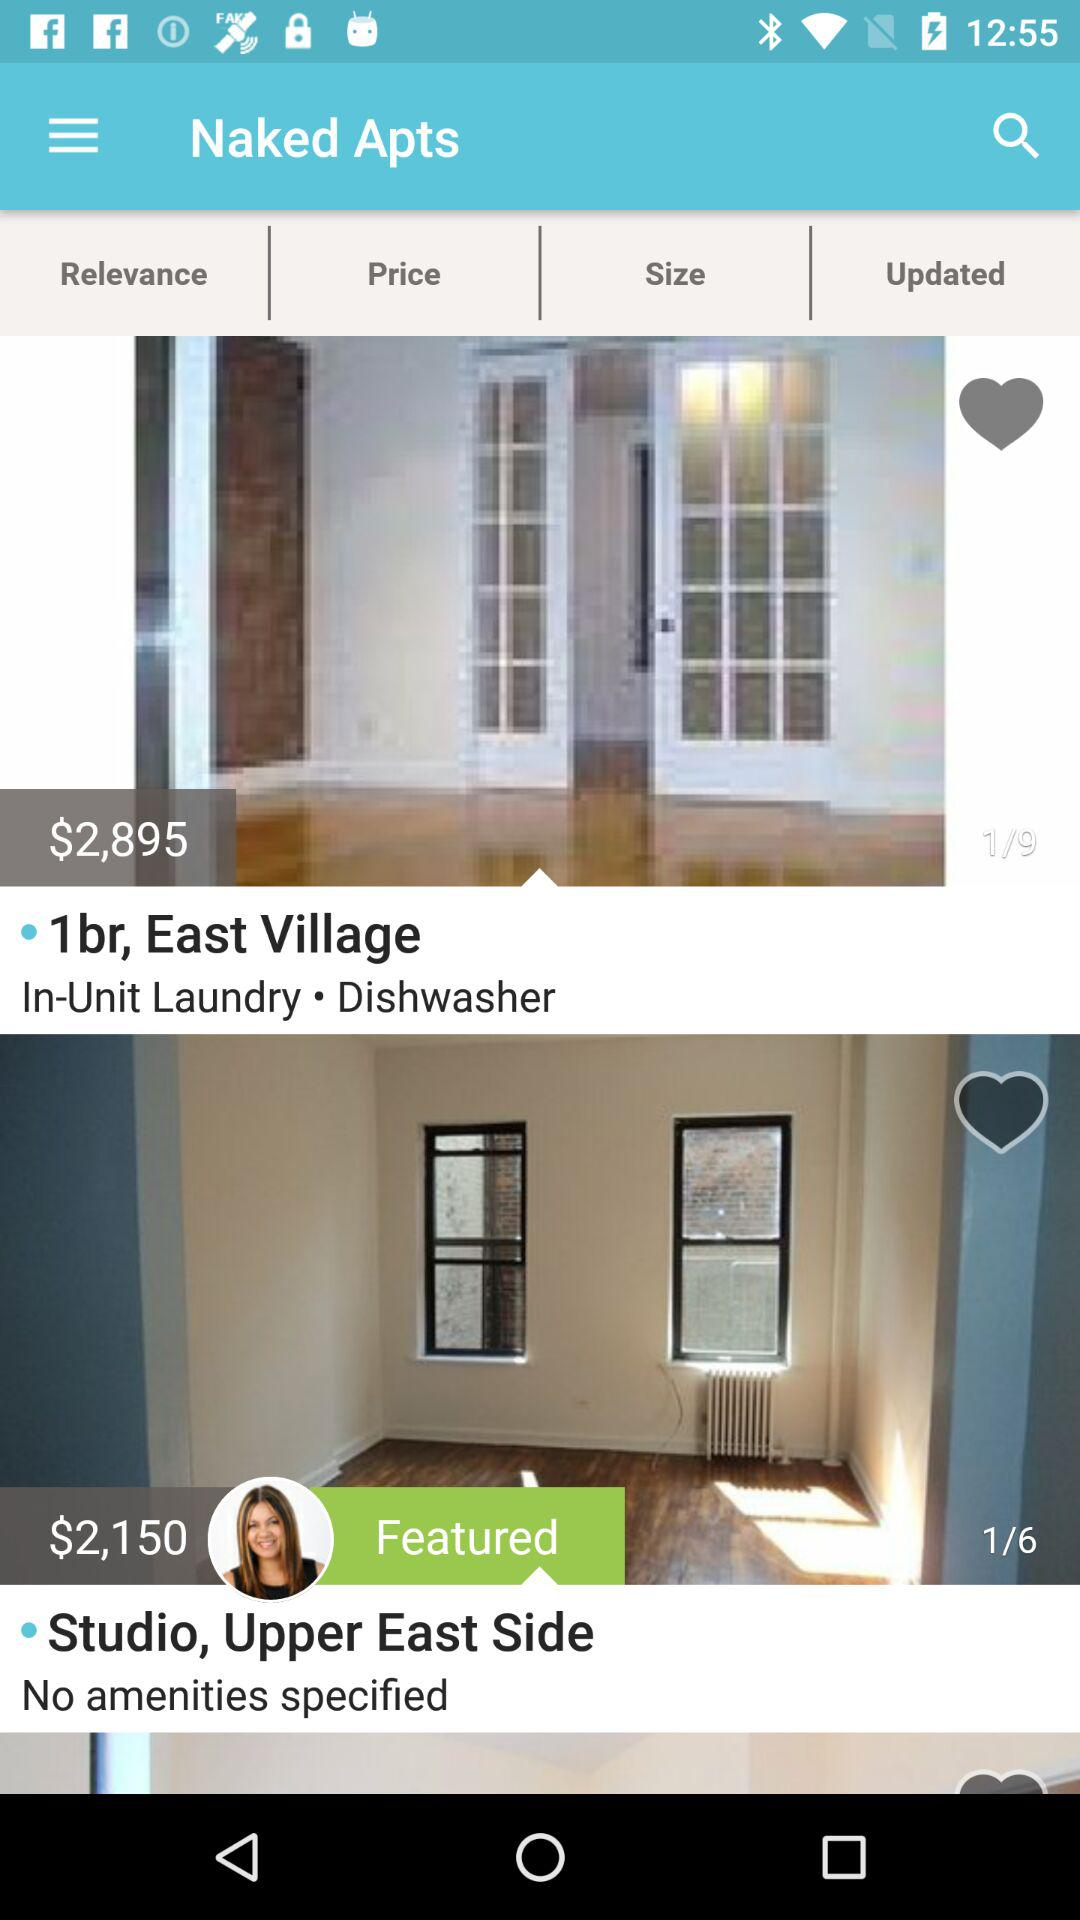What is the rent of the "1br, East Village"? The rent of the "1br, East Village" is $2,895. 